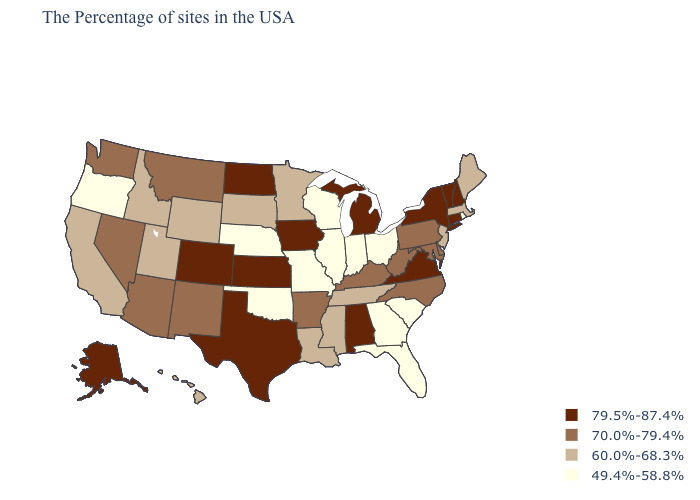What is the lowest value in the USA?
Concise answer only. 49.4%-58.8%. Does South Carolina have the lowest value in the USA?
Short answer required. Yes. Name the states that have a value in the range 49.4%-58.8%?
Keep it brief. Rhode Island, South Carolina, Ohio, Florida, Georgia, Indiana, Wisconsin, Illinois, Missouri, Nebraska, Oklahoma, Oregon. Name the states that have a value in the range 70.0%-79.4%?
Give a very brief answer. Delaware, Maryland, Pennsylvania, North Carolina, West Virginia, Kentucky, Arkansas, New Mexico, Montana, Arizona, Nevada, Washington. What is the value of South Dakota?
Be succinct. 60.0%-68.3%. Name the states that have a value in the range 49.4%-58.8%?
Concise answer only. Rhode Island, South Carolina, Ohio, Florida, Georgia, Indiana, Wisconsin, Illinois, Missouri, Nebraska, Oklahoma, Oregon. Name the states that have a value in the range 60.0%-68.3%?
Write a very short answer. Maine, Massachusetts, New Jersey, Tennessee, Mississippi, Louisiana, Minnesota, South Dakota, Wyoming, Utah, Idaho, California, Hawaii. What is the highest value in states that border Indiana?
Quick response, please. 79.5%-87.4%. What is the highest value in states that border New Hampshire?
Give a very brief answer. 79.5%-87.4%. Does Texas have the highest value in the South?
Be succinct. Yes. Which states have the lowest value in the Northeast?
Give a very brief answer. Rhode Island. Does Texas have the same value as Idaho?
Be succinct. No. Name the states that have a value in the range 49.4%-58.8%?
Quick response, please. Rhode Island, South Carolina, Ohio, Florida, Georgia, Indiana, Wisconsin, Illinois, Missouri, Nebraska, Oklahoma, Oregon. What is the highest value in the MidWest ?
Give a very brief answer. 79.5%-87.4%. Does South Carolina have a higher value than Florida?
Concise answer only. No. 